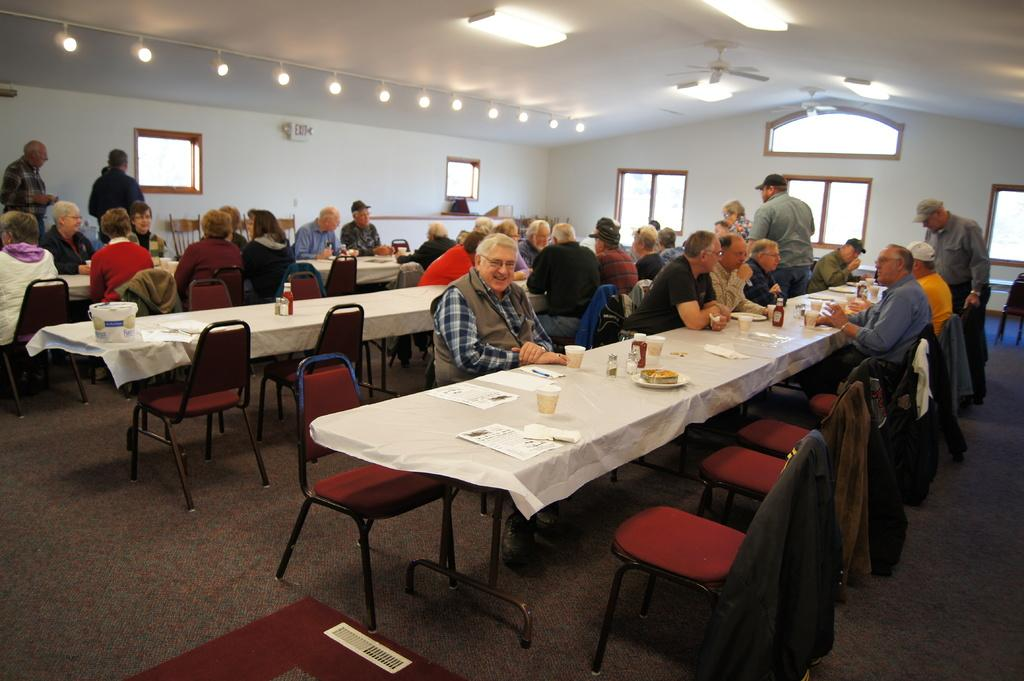What are the people in the image doing? The people in the image are sitting at tables. How are the tables arranged in the image? The tables are arranged in a row. What activity are the people engaged in while sitting at the tables? The people are having food. Can you see any ocean in the image? No, there is no ocean present in the image. What type of fruit is being served at the tables in the image? The provided facts do not mention any fruit being served in the image. 